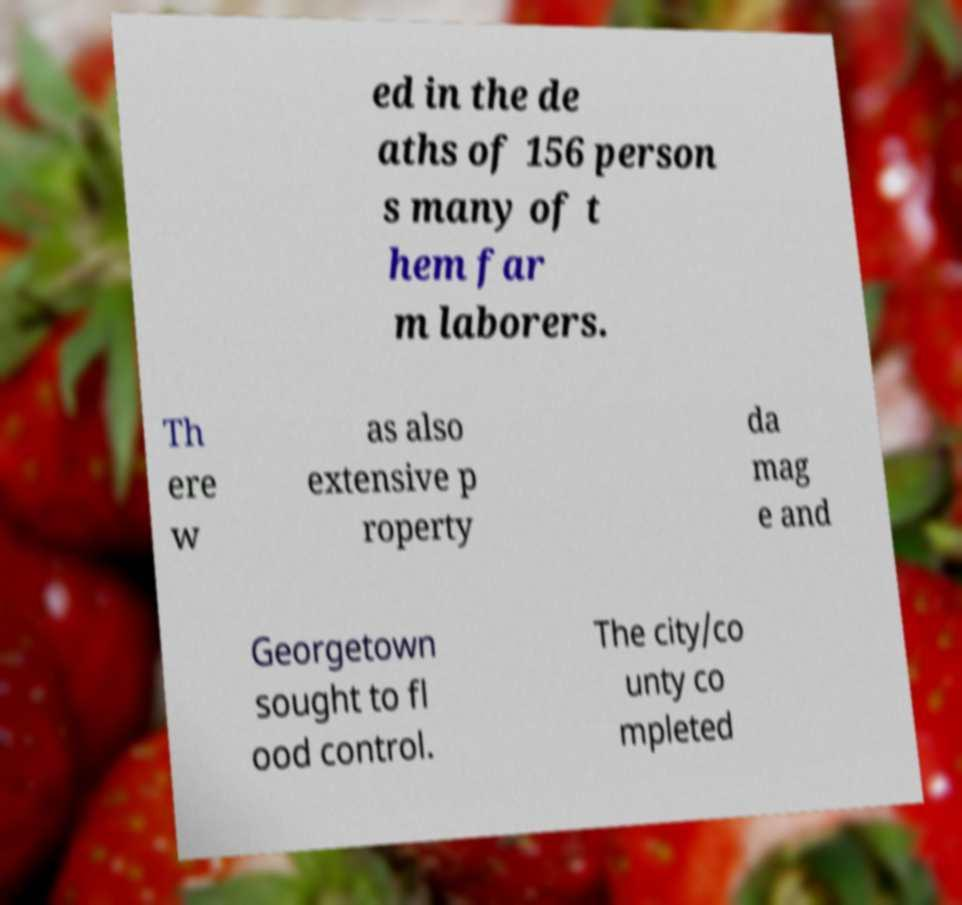Can you read and provide the text displayed in the image?This photo seems to have some interesting text. Can you extract and type it out for me? ed in the de aths of 156 person s many of t hem far m laborers. Th ere w as also extensive p roperty da mag e and Georgetown sought to fl ood control. The city/co unty co mpleted 